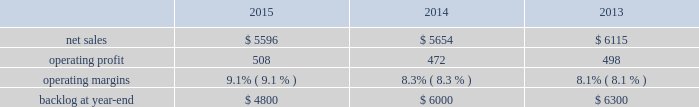Backlog backlog increased in 2015 compared to 2014 primarily due to higher orders on f-35 and c-130 programs .
Backlog decreased slightly in 2014 compared to 2013 primarily due to lower orders on f-16 and f-22 programs .
Trends we expect aeronautics 2019 2016 net sales to increase in the mid-single digit percentage range as compared to 2015 due to increased volume on the f-35 and c-130 programs , partially offset by decreased volume on the f-16 program .
Operating profit is also expected to increase in the low single-digit percentage range , driven by increased volume on the f-35 program offset by contract mix that results in a slight decrease in operating margins between years .
Information systems & global solutions our is&gs business segment provides advanced technology systems and expertise , integrated information technology solutions and management services across a broad spectrum of applications for civil , defense , intelligence and other government customers .
Is&gs 2019 technical services business provides a comprehensive portfolio of technical and sustainment services .
Is&gs has a portfolio of many smaller contracts as compared to our other business segments .
Is&gs has been impacted by the continued downturn in certain federal agencies 2019 information technology budgets and increased re-competition on existing contracts coupled with the fragmentation of large contracts into multiple smaller contracts that are awarded primarily on the basis of price .
Is&gs 2019 operating results included the following ( in millions ) : .
2015 compared to 2014 is&gs 2019 net sales decreased $ 58 million , or 1% ( 1 % ) , in 2015 as compared to 2014 .
The decrease was attributable to lower net sales of approximately $ 395 million as a result of key program completions , lower customer funding levels and increased competition , coupled with the fragmentation of existing large contracts into multiple smaller contracts that are awarded primarily on the basis of price when re-competed ( including cms-citic ) .
These decreases were partially offset by higher net sales of approximately $ 230 million for businesses acquired in 2014 ; and approximately $ 110 million due to the start-up of new programs and growth in recently awarded programs .
Is&gs 2019 operating profit increased $ 36 million , or 8% ( 8 % ) , in 2015 as compared to 2014 .
The increase was attributable to improved program performance and risk retirements , offset by decreased operating profit resulting from the activities mentioned above for net sales .
Adjustments not related to volume , including net profit booking rate adjustments and other matters , were approximately $ 70 million higher in 2015 compared to 2014 .
2014 compared to 2013 is&gs 2019 net sales decreased $ 461 million , or 8% ( 8 % ) , in 2014 as compared to 2013 .
The decrease was primarily attributable to lower net sales of about $ 475 million due to the wind-down or completion of certain programs , driven by reductions in direct warfighter support ( including jieddo ) ; and approximately $ 320 million due to decreased volume in technical services programs reflecting market pressures .
The decreases were offset by higher net sales of about $ 330 million due to the start-up of new programs , growth in recently awarded programs and integration of recently acquired companies .
Is&gs 2019 operating profit decreased $ 26 million , or 5% ( 5 % ) , in 2014 as compared to 2013 .
The decrease was primarily attributable to the activities mentioned above for sales , partially offset by severance recoveries related to the restructuring announced in november 2013 of approximately $ 20 million in 2014 .
Adjustments not related to volume , including net profit booking rate adjustments , were comparable in 2014 and 2013. .
What was the percentage of the change in the backlog at year-end \\n? 
Computations: ((6000 - 6300) / 6300)
Answer: -0.04762. 